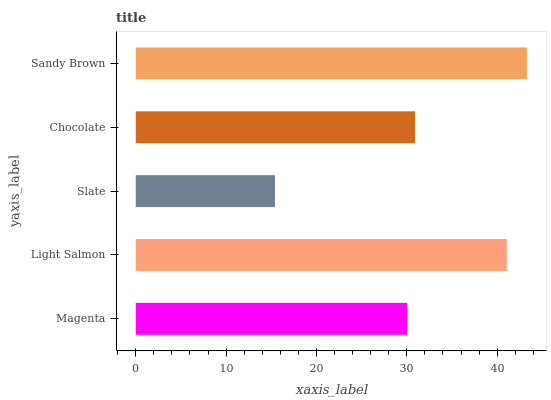Is Slate the minimum?
Answer yes or no. Yes. Is Sandy Brown the maximum?
Answer yes or no. Yes. Is Light Salmon the minimum?
Answer yes or no. No. Is Light Salmon the maximum?
Answer yes or no. No. Is Light Salmon greater than Magenta?
Answer yes or no. Yes. Is Magenta less than Light Salmon?
Answer yes or no. Yes. Is Magenta greater than Light Salmon?
Answer yes or no. No. Is Light Salmon less than Magenta?
Answer yes or no. No. Is Chocolate the high median?
Answer yes or no. Yes. Is Chocolate the low median?
Answer yes or no. Yes. Is Magenta the high median?
Answer yes or no. No. Is Sandy Brown the low median?
Answer yes or no. No. 